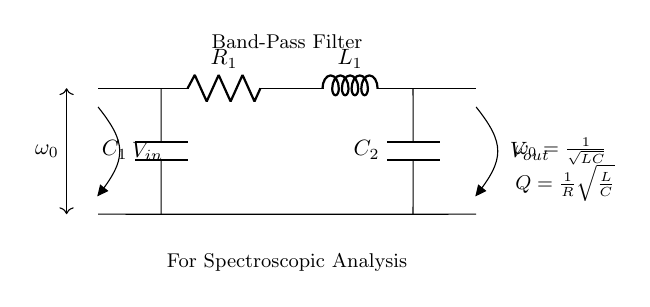What is the configuration of the filter? The filter is a band-pass filter, as indicated in the circuit diagram. This type of filter allows signals within a certain frequency range to pass through while attenuating signals outside that range.
Answer: Band-pass filter What components are used in this circuit? The circuit includes two resistors, two capacitors, and one inductor. The components essential for the band-pass function are labeled as R1, C1, C2, and L1 in the diagram.
Answer: Resistors, capacitors, inductor What is the formula for the center frequency? The center frequency is given by the formula ω0 equals one divided by the square root of the product of inductance and capacitance. This formula helps determine the specific frequency at which the filter operates optimally.
Answer: ω0 equals one over the square root of LC How does resistance affect the quality factor (Q)? The quality factor Q is inversely proportional to resistance as shown in the formula Q equals one divided by R times the square root of L over C. A lower resistance can lead to a higher quality factor, indicating a sharper resonance peak in the filter response.
Answer: Inversely proportional What happens to frequencies outside the passband? Frequencies that fall outside the designated passband of the filter are attenuated, meaning their amplitudes are reduced significantly, thus isolating the desired range of frequencies for analysis in spectroscopic studies.
Answer: Attenuated What is the significance of the symbol "Vout"? The symbol "Vout" represents the output voltage of the filter circuit, which is taken across the load or output terminals after the input voltage has passed through the filtering components.
Answer: Output voltage 